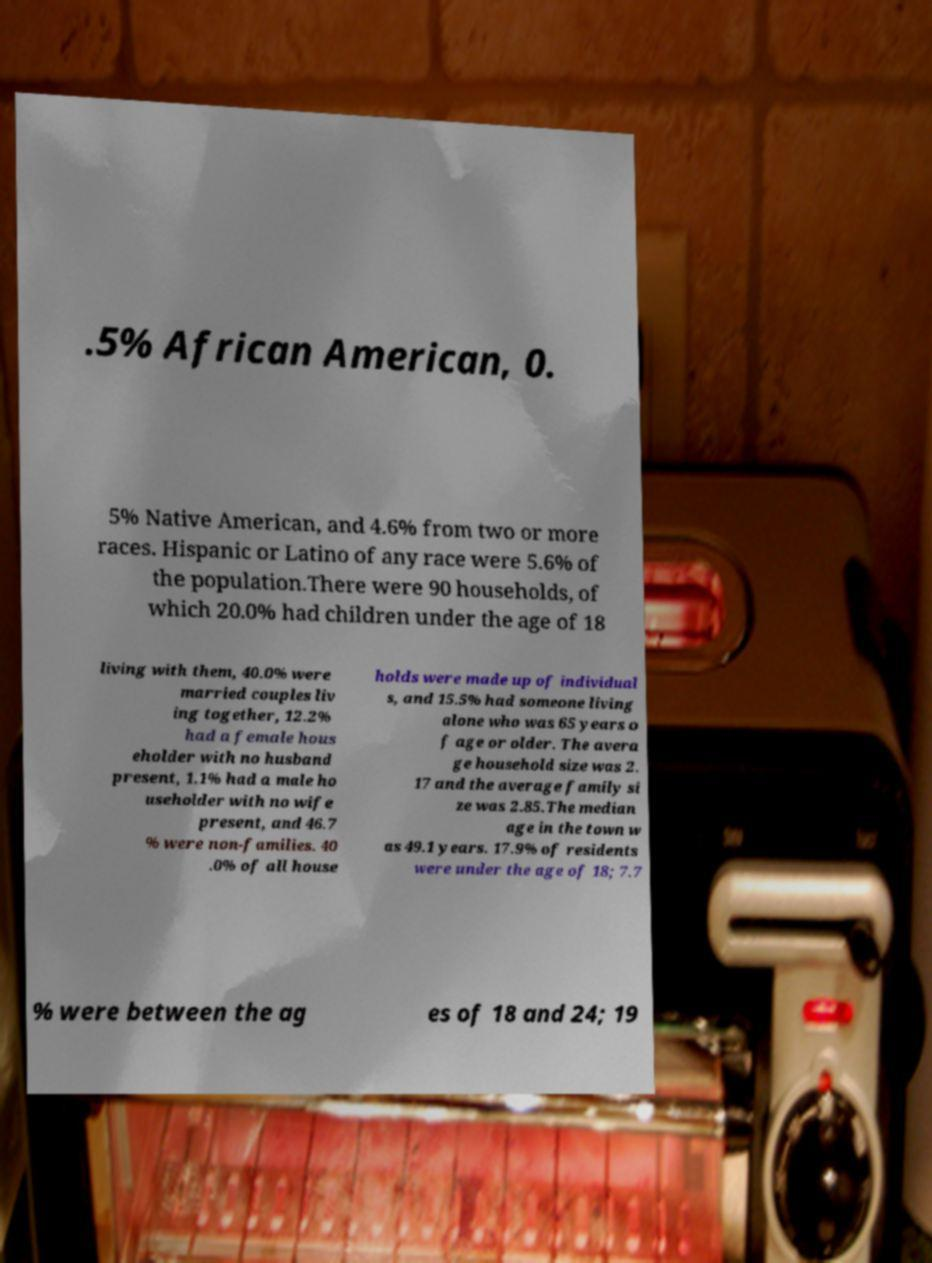There's text embedded in this image that I need extracted. Can you transcribe it verbatim? .5% African American, 0. 5% Native American, and 4.6% from two or more races. Hispanic or Latino of any race were 5.6% of the population.There were 90 households, of which 20.0% had children under the age of 18 living with them, 40.0% were married couples liv ing together, 12.2% had a female hous eholder with no husband present, 1.1% had a male ho useholder with no wife present, and 46.7 % were non-families. 40 .0% of all house holds were made up of individual s, and 15.5% had someone living alone who was 65 years o f age or older. The avera ge household size was 2. 17 and the average family si ze was 2.85.The median age in the town w as 49.1 years. 17.9% of residents were under the age of 18; 7.7 % were between the ag es of 18 and 24; 19 